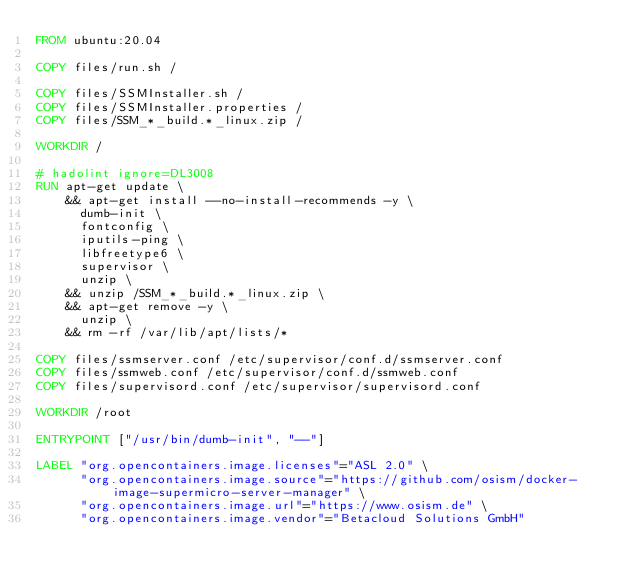<code> <loc_0><loc_0><loc_500><loc_500><_Dockerfile_>FROM ubuntu:20.04

COPY files/run.sh /

COPY files/SSMInstaller.sh /
COPY files/SSMInstaller.properties /
COPY files/SSM_*_build.*_linux.zip /

WORKDIR /

# hadolint ignore=DL3008
RUN apt-get update \
    && apt-get install --no-install-recommends -y \
      dumb-init \
      fontconfig \
      iputils-ping \
      libfreetype6 \
      supervisor \
      unzip \
    && unzip /SSM_*_build.*_linux.zip \
    && apt-get remove -y \
      unzip \
    && rm -rf /var/lib/apt/lists/*

COPY files/ssmserver.conf /etc/supervisor/conf.d/ssmserver.conf
COPY files/ssmweb.conf /etc/supervisor/conf.d/ssmweb.conf
COPY files/supervisord.conf /etc/supervisor/supervisord.conf

WORKDIR /root

ENTRYPOINT ["/usr/bin/dumb-init", "--"]

LABEL "org.opencontainers.image.licenses"="ASL 2.0" \
      "org.opencontainers.image.source"="https://github.com/osism/docker-image-supermicro-server-manager" \
      "org.opencontainers.image.url"="https://www.osism.de" \
      "org.opencontainers.image.vendor"="Betacloud Solutions GmbH"
</code> 